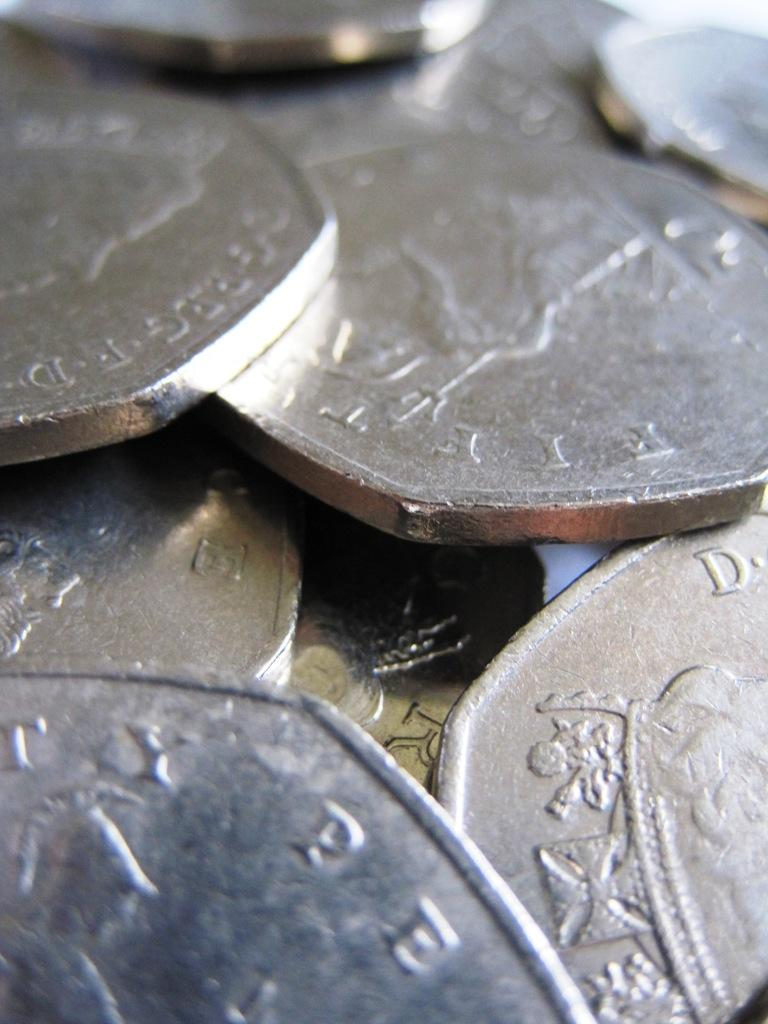What objects are present in the image? There are coins in the image. What type of pen can be seen writing on the dust in the image? There is no pen or dust present in the image; it only features coins. Is there a volleyball visible in the image? There is no volleyball present in the image. 